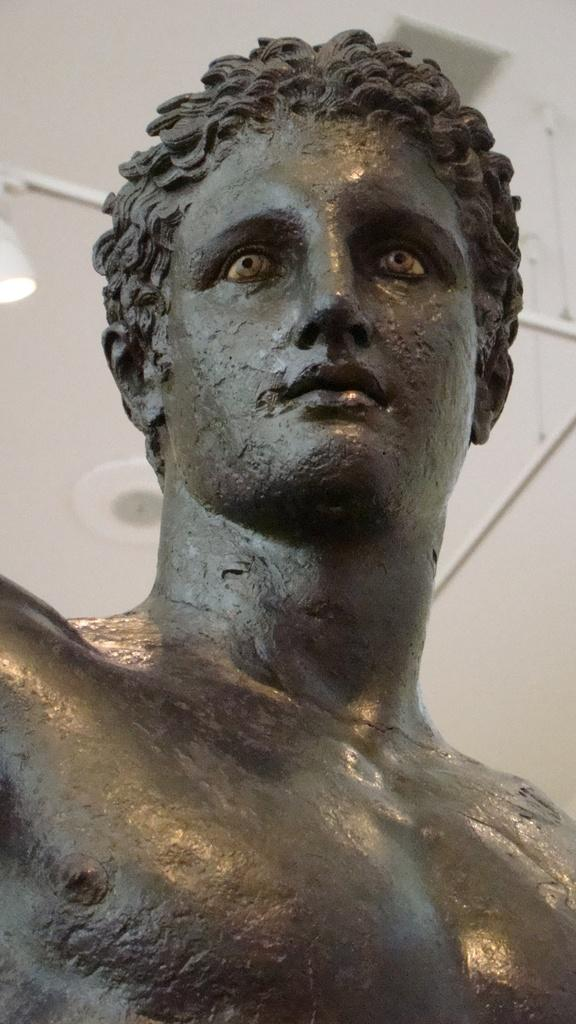What is the main subject of the image? There is a sculpture of a person in the image. What can be seen to the left of the image? There is a light truncated towards the left of the image. What type of structure is visible in the image? There is a roof in the image. What is present on the roof? There are objects on the roof. What type of riddle is the sculpture trying to solve in the image? There is no riddle present in the image; it features a sculpture of a person. Can you tell me how many mountains are visible in the image? There are no mountains visible in the image. 